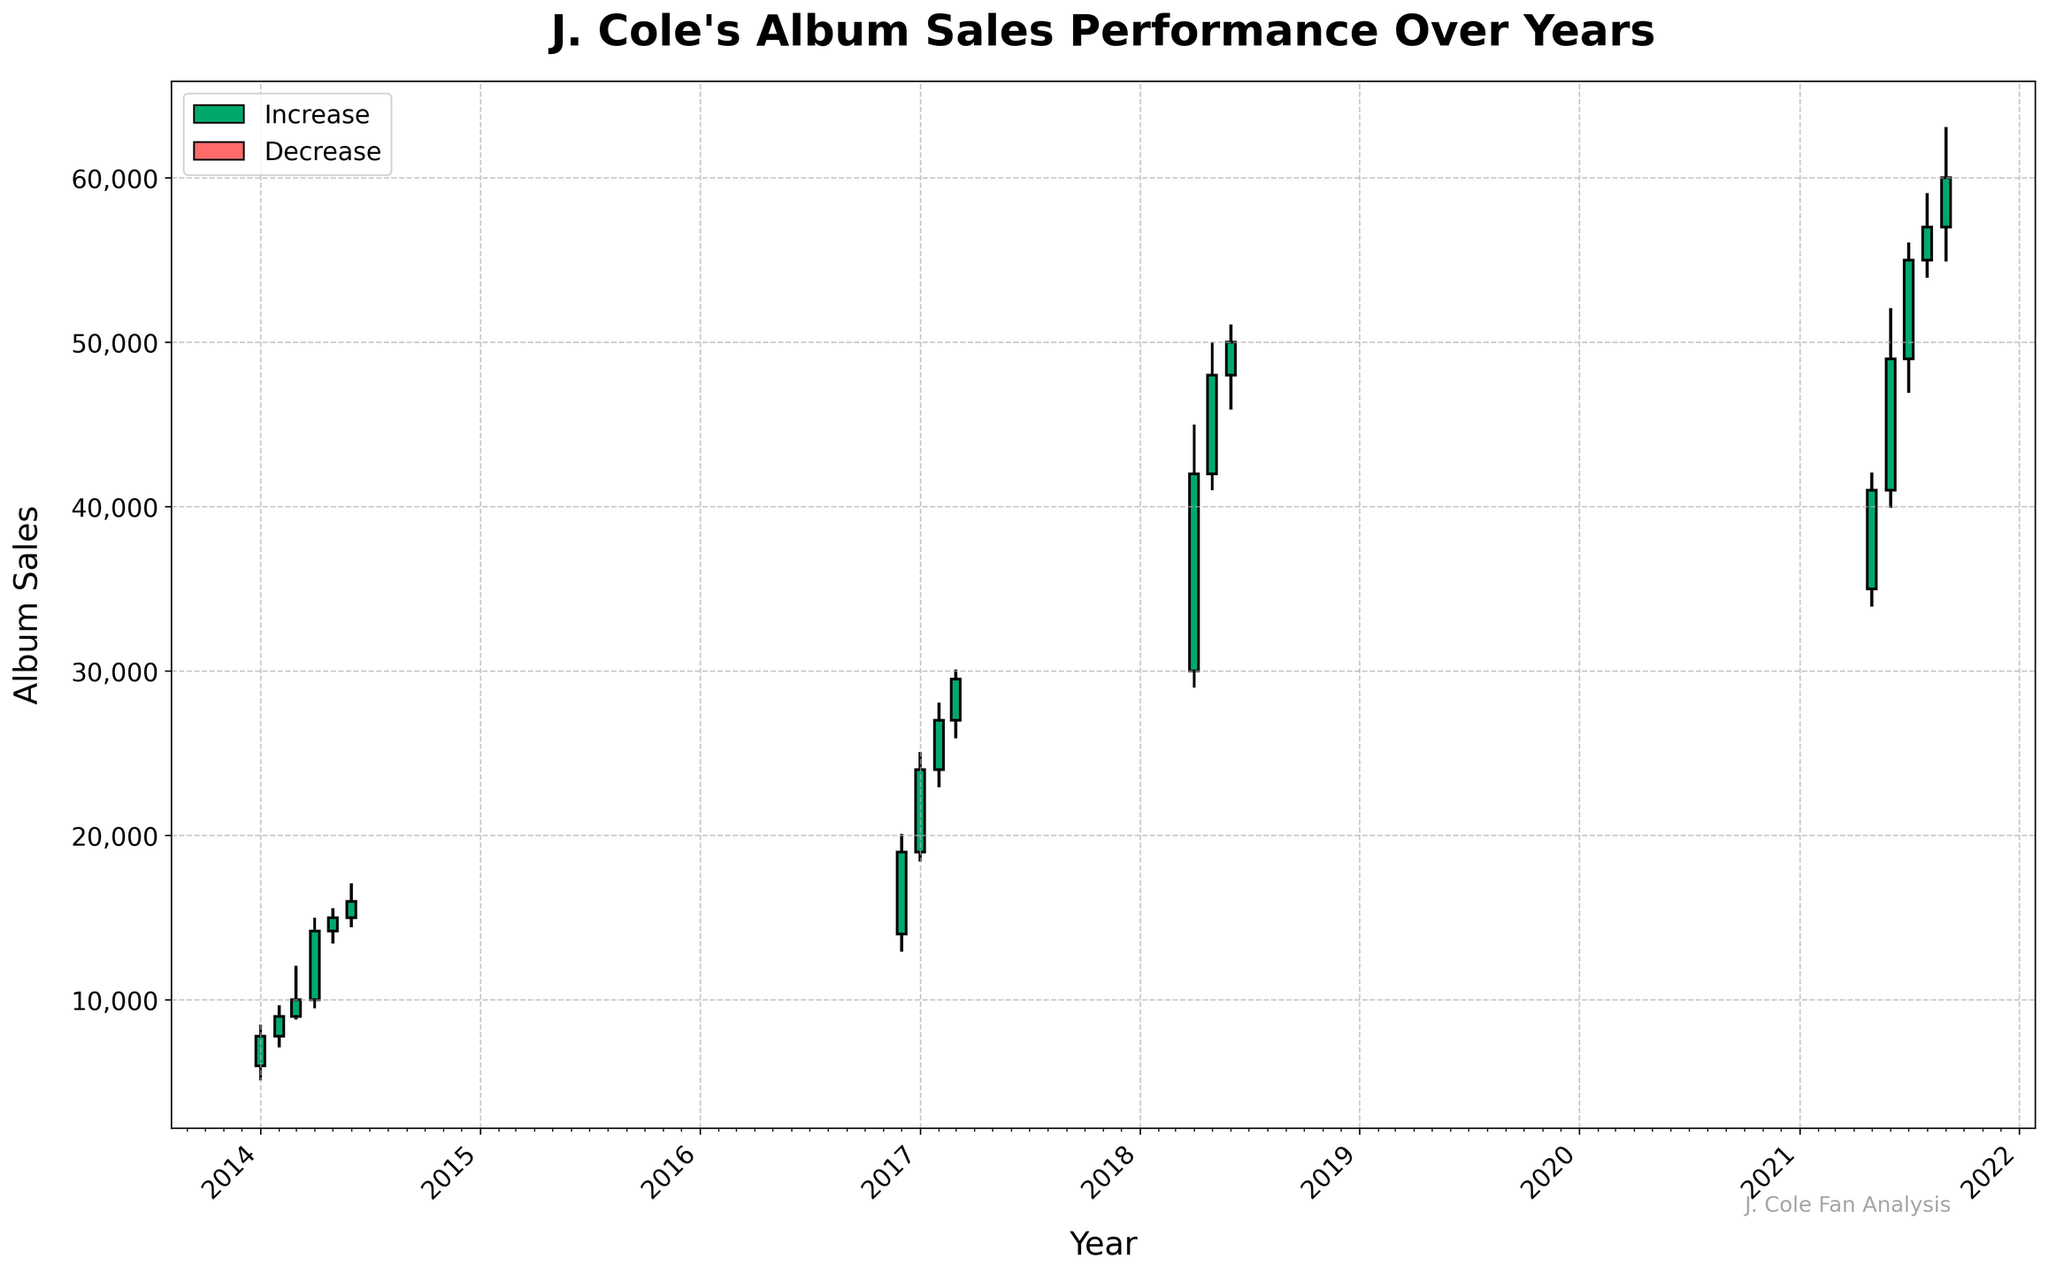What is the title of the plot? The title of the plot is generally located at the top of the figure. It provides a quick summary of what the figure is about. Here, the title reads "J. Cole's Album Sales Performance Over Years".
Answer: J. Cole's Album Sales Performance Over Years How many measurement points are displayed in the plot? The plot uses candlesticks to represent data points for different months in various years. By counting the number of candlesticks (both green and red), we can determine there are 16 data points.
Answer: 16 Which month and year had the highest album sales value of 63,000? The highest value is depicted by the highest position of the upper shadow in the candlestick. Here, we can see it happens in 2021-09.
Answer: 2021-09 In which month and year did J. Cole's album sales decrease the most within the month? Look for the longest red candlestick, which represents a significant drop within the month. The longest red candlestick is observed in 2016-12, indicating a noticeable decrease.
Answer: 2016-12 What are the album sales values (open and close) for May 2021? For the specified month, note the starting and ending heights of the candlestick. For 2021-05, the open sales value is 35,000 and the close sales value is 41,000.
Answer: 35,000 and 41,000 What is the difference in album sales for the month with the highest close value and the month with the lowest close value? Identify the months with the highest (2021-09 at 60,000) and lowest (2014-01 at 7,800) close values from the candlesticks and calculate the difference: 60,000 - 7,800 = 52,200.
Answer: 52,200 Which year had the most consistent increase in album sales over consecutive months? Consistent increases are shown by consecutive green candlesticks. In 2021, from May to September, there are consistent increases in sales, showing stability.
Answer: 2021 Between 2017 and 2018, how much did the maximum album sales increase from the last value in 2017 to the first value in 2018? Compare the highest album sales in December 2017 (29,500) to the first value in April 2018 (45,000), calculating the increase: 45,000 - 29,500 = 15,500.
Answer: 15,500 What is the median closing album sales across all data points? To find the median, list all closing values: 7800, 9000, 10000, 14200, 15000, 16000, 19000, 24000, 27000, 29500, 42000, 48000, 50000, 41000, 49000, 60000. Sort and find the middle value(s): (27,000 + 29,500)/2 = 28,250.
Answer: 28,250 